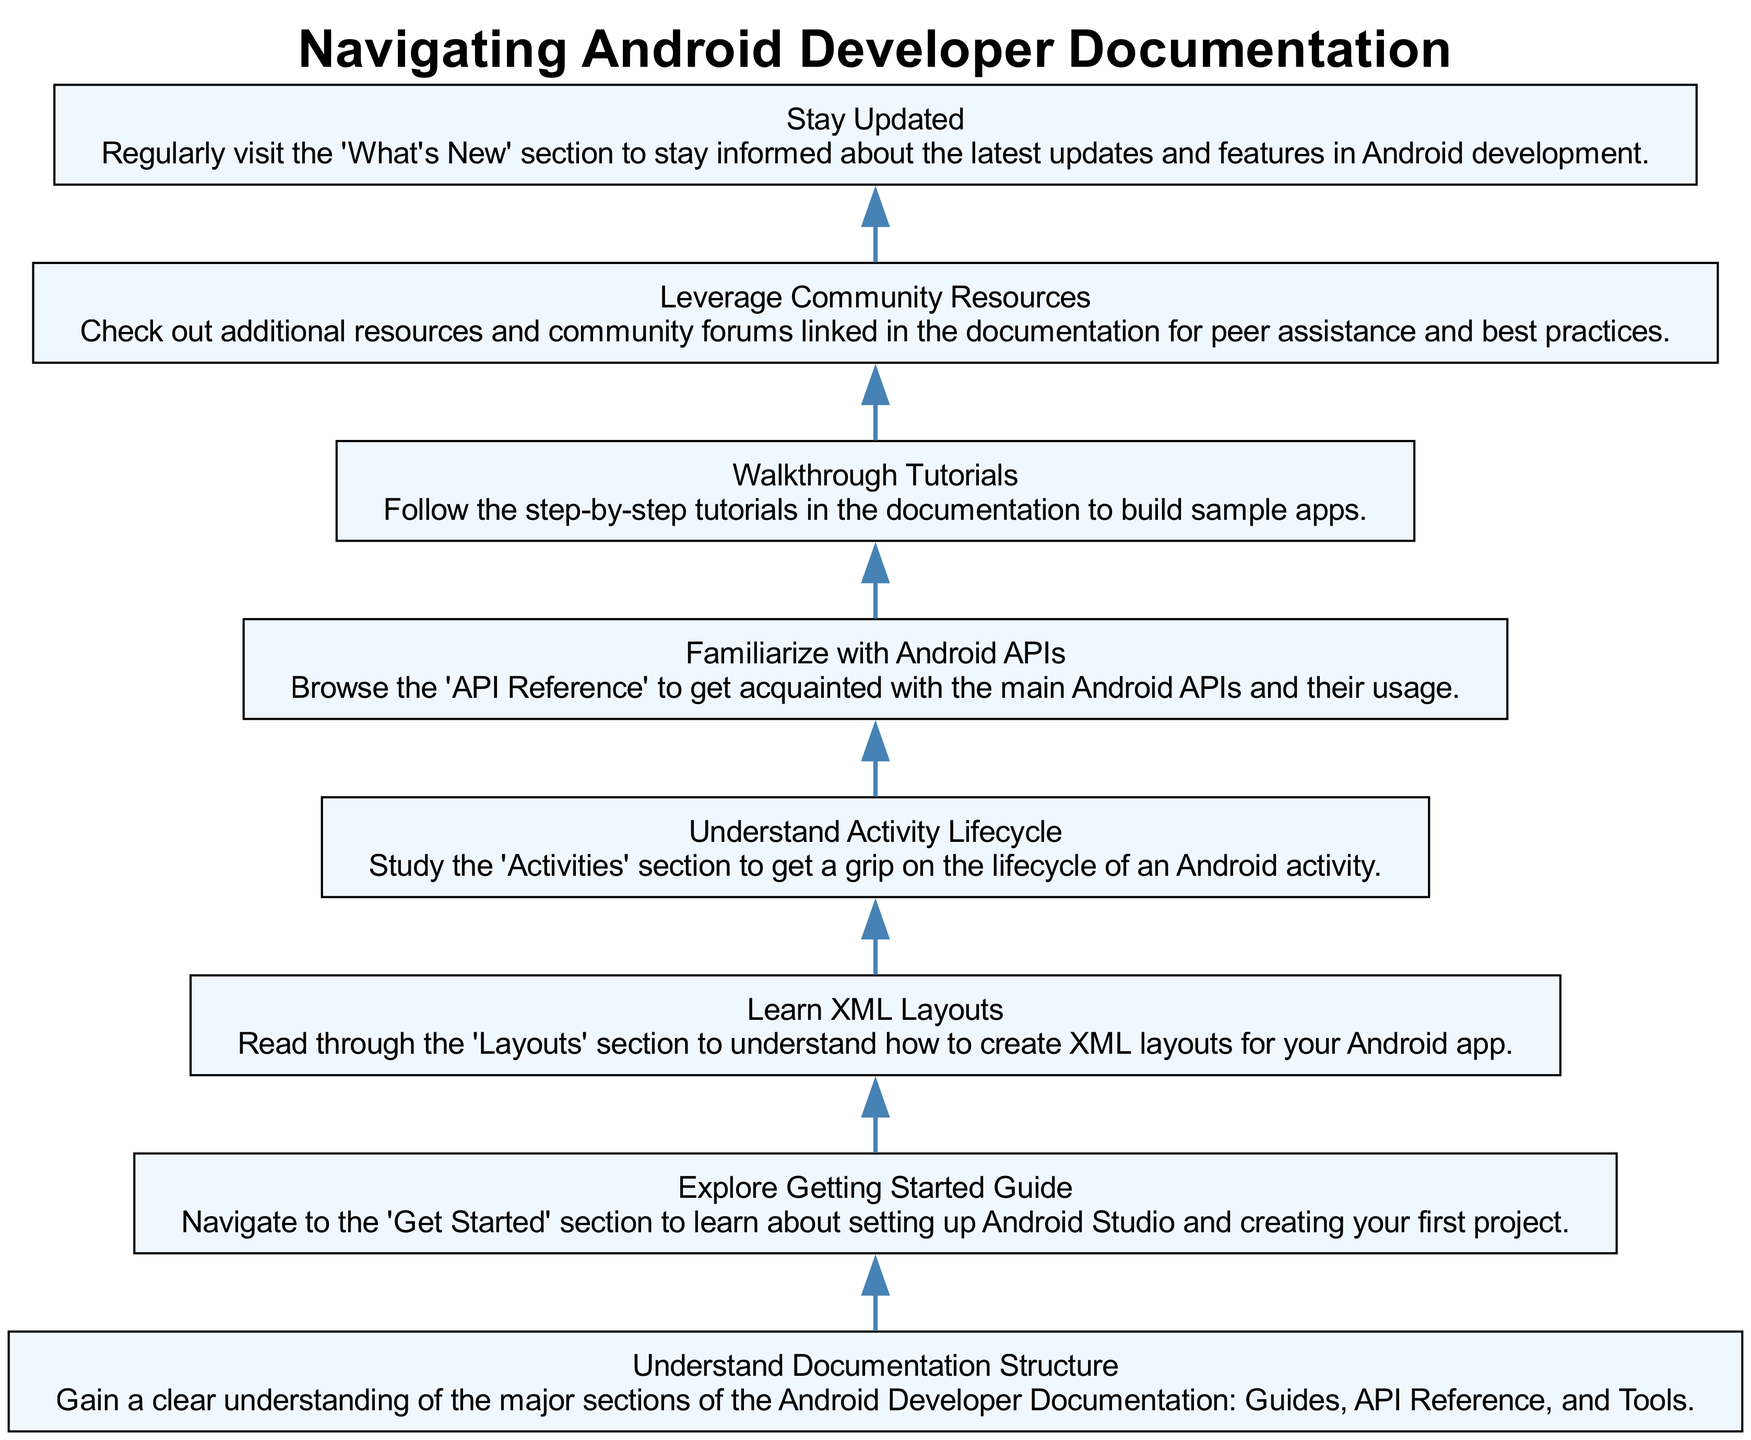What is the first step to navigate the documentation? The diagram indicates that the first step is to understand the documentation structure, as it is the starting node in the flow.
Answer: Understand Documentation Structure Which section follows learning XML layouts? After learning XML layouts (node 3), the next step according to the diagram is to understand the activity lifecycle (node 4).
Answer: Understand Activity Lifecycle How many main sections of the documentation are outlined? The diagram outlines eight steps or nodes in total, indicating eight major topics to navigate.
Answer: Eight What resource should be checked for updates on Android development? The last step in the diagram advises checking the 'What’s New' section regularly for the latest updates.
Answer: What's New What would you explore after getting started with the guide? After exploring the getting started guide, the next section to study is XML layouts, as indicated in the flow from node 2 to node 3.
Answer: Learn XML Layouts What is the relationship between familiarizing with Android APIs and walking through tutorials? The relationship is sequential; after familiarizing oneself with Android APIs (node 5), the next step is to walk through tutorials (node 6), indicating a flow of learning through practical application.
Answer: Sequential What is the last node in the diagram? The final node in the diagram is to stay updated, as the flow chart concludes with this step, completing the navigation process.
Answer: Stay Updated How many nodes must you traverse before leveraging community resources? According to the diagram, you must traverse six nodes before reaching the node that focuses on leveraging community resources, starting from the first step to number seven.
Answer: Six What do you do after studying the activity lifecycle? Once you understand the activity lifecycle, the next action is to familiarize yourself with Android APIs, directly following node 4.
Answer: Familiarize with Android APIs 